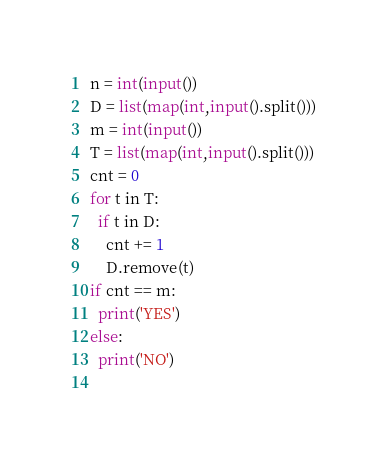<code> <loc_0><loc_0><loc_500><loc_500><_Python_>n = int(input())
D = list(map(int,input().split()))
m = int(input())
T = list(map(int,input().split()))
cnt = 0
for t in T:
  if t in D:
    cnt += 1
    D.remove(t)
if cnt == m:
  print('YES')
else:
  print('NO')
  </code> 